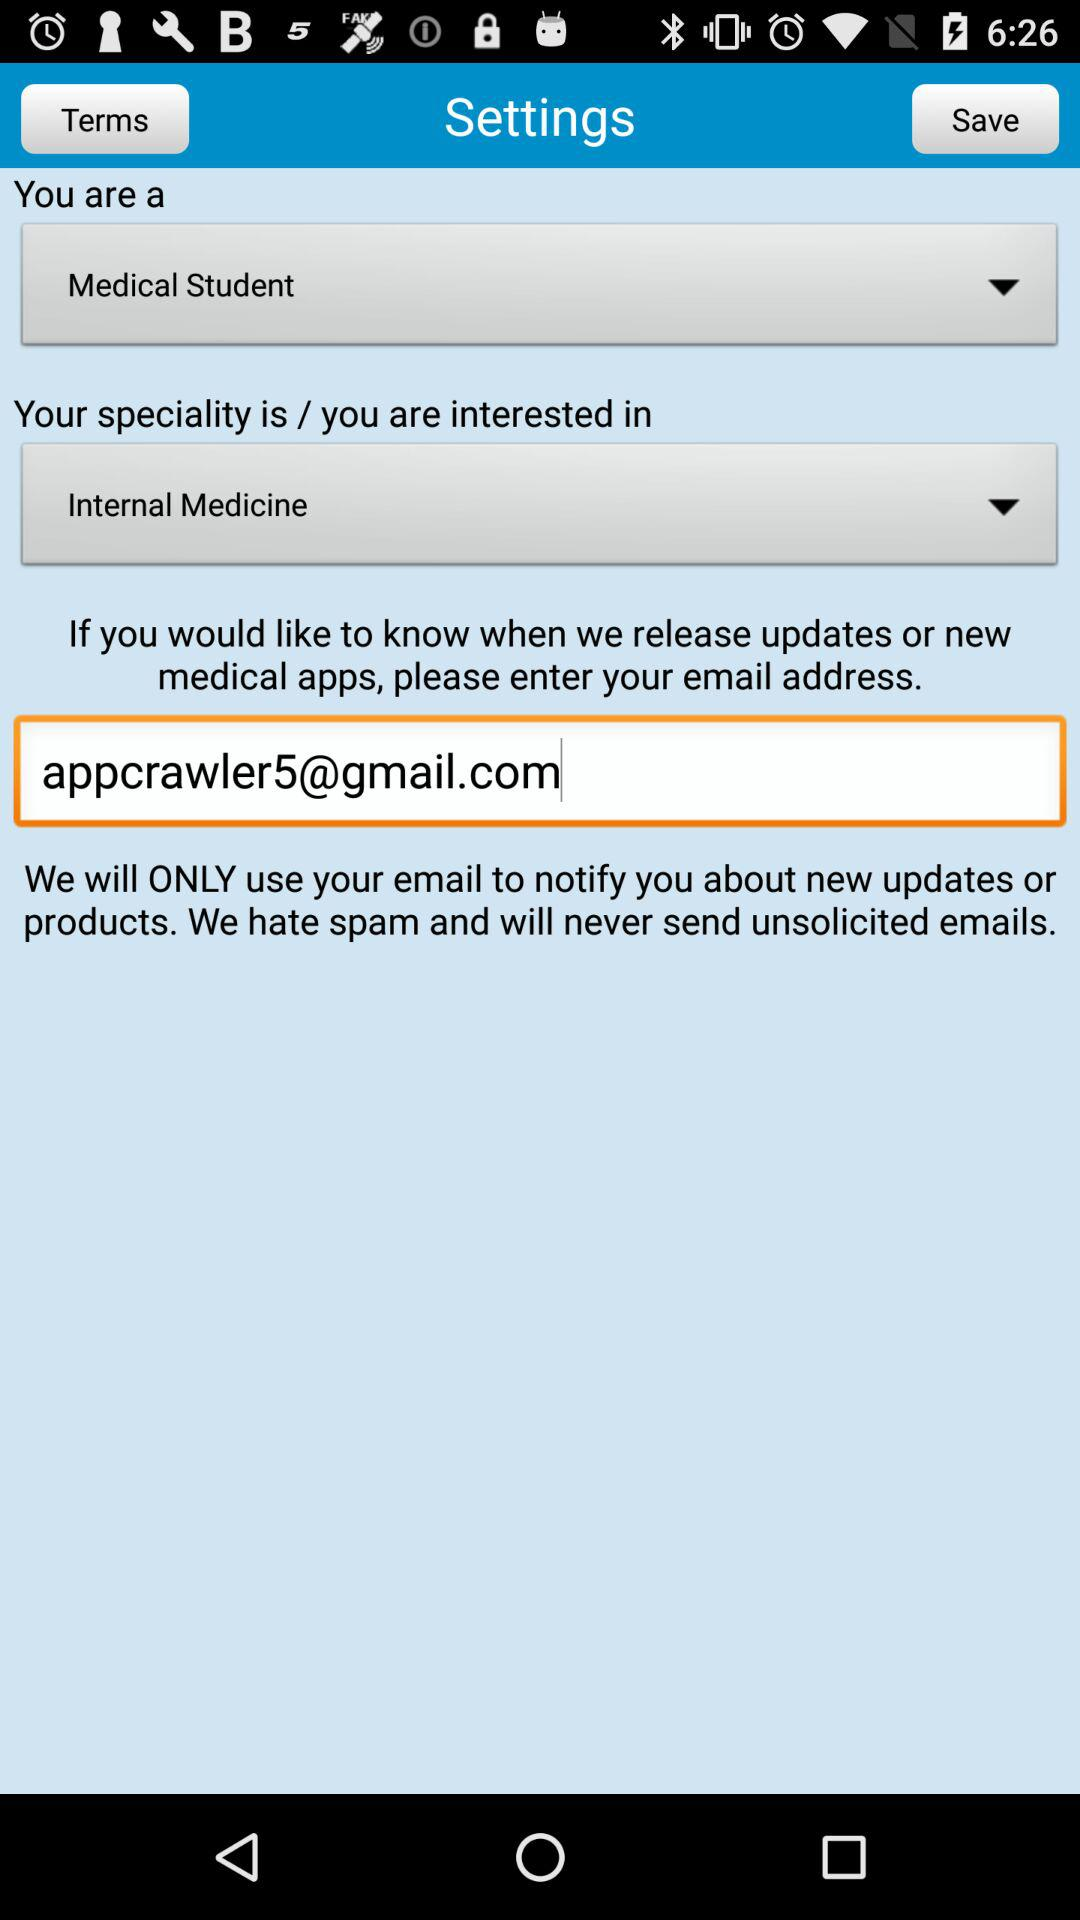What is the user's specialization? The user's specialization is "Internal Medicine". 